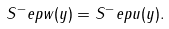Convert formula to latex. <formula><loc_0><loc_0><loc_500><loc_500>S ^ { - } _ { \ } e p w ( y ) = S ^ { - } _ { \ } e p u ( y ) .</formula> 